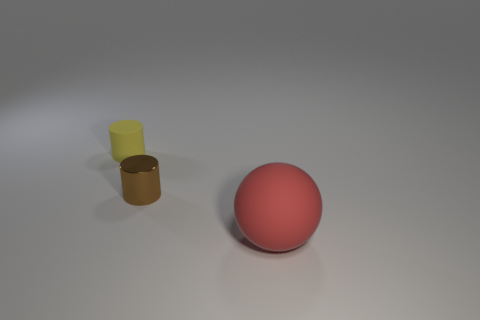What textures are visible on the objects shown in the image? The objects display two types of textures: the red sphere and the yellow cylinder have a matte finish, while the gold-colored cylinder has a glossy, reflective texture. Which object looks the smoothest? The gold-colored cylinder looks the smoothest due to its glossy texture and reflective surface. 